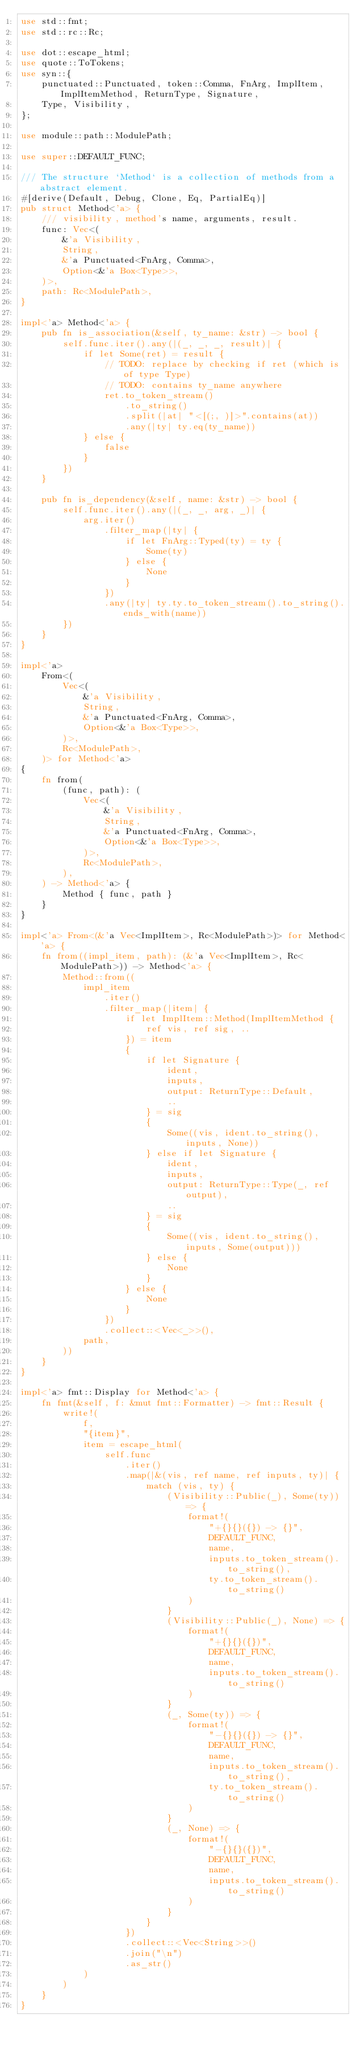<code> <loc_0><loc_0><loc_500><loc_500><_Rust_>use std::fmt;
use std::rc::Rc;

use dot::escape_html;
use quote::ToTokens;
use syn::{
    punctuated::Punctuated, token::Comma, FnArg, ImplItem, ImplItemMethod, ReturnType, Signature,
    Type, Visibility,
};

use module::path::ModulePath;

use super::DEFAULT_FUNC;

/// The structure `Method` is a collection of methods from a abstract element.
#[derive(Default, Debug, Clone, Eq, PartialEq)]
pub struct Method<'a> {
    /// visibility, method's name, arguments, result.
    func: Vec<(
        &'a Visibility,
        String,
        &'a Punctuated<FnArg, Comma>,
        Option<&'a Box<Type>>,
    )>,
    path: Rc<ModulePath>,
}

impl<'a> Method<'a> {
    pub fn is_association(&self, ty_name: &str) -> bool {
        self.func.iter().any(|(_, _, _, result)| {
            if let Some(ret) = result {
                // TODO: replace by checking if ret (which is of type Type)
                // TODO: contains ty_name anywhere
                ret.to_token_stream()
                    .to_string()
                    .split(|at| "<[(;, )]>".contains(at))
                    .any(|ty| ty.eq(ty_name))
            } else {
                false
            }
        })
    }

    pub fn is_dependency(&self, name: &str) -> bool {
        self.func.iter().any(|(_, _, arg, _)| {
            arg.iter()
                .filter_map(|ty| {
                    if let FnArg::Typed(ty) = ty {
                        Some(ty)
                    } else {
                        None
                    }
                })
                .any(|ty| ty.ty.to_token_stream().to_string().ends_with(name))
        })
    }
}

impl<'a>
    From<(
        Vec<(
            &'a Visibility,
            String,
            &'a Punctuated<FnArg, Comma>,
            Option<&'a Box<Type>>,
        )>,
        Rc<ModulePath>,
    )> for Method<'a>
{
    fn from(
        (func, path): (
            Vec<(
                &'a Visibility,
                String,
                &'a Punctuated<FnArg, Comma>,
                Option<&'a Box<Type>>,
            )>,
            Rc<ModulePath>,
        ),
    ) -> Method<'a> {
        Method { func, path }
    }
}

impl<'a> From<(&'a Vec<ImplItem>, Rc<ModulePath>)> for Method<'a> {
    fn from((impl_item, path): (&'a Vec<ImplItem>, Rc<ModulePath>)) -> Method<'a> {
        Method::from((
            impl_item
                .iter()
                .filter_map(|item| {
                    if let ImplItem::Method(ImplItemMethod {
                        ref vis, ref sig, ..
                    }) = item
                    {
                        if let Signature {
                            ident,
                            inputs,
                            output: ReturnType::Default,
                            ..
                        } = sig
                        {
                            Some((vis, ident.to_string(), inputs, None))
                        } else if let Signature {
                            ident,
                            inputs,
                            output: ReturnType::Type(_, ref output),
                            ..
                        } = sig
                        {
                            Some((vis, ident.to_string(), inputs, Some(output)))
                        } else {
                            None
                        }
                    } else {
                        None
                    }
                })
                .collect::<Vec<_>>(),
            path,
        ))
    }
}

impl<'a> fmt::Display for Method<'a> {
    fn fmt(&self, f: &mut fmt::Formatter) -> fmt::Result {
        write!(
            f,
            "{item}",
            item = escape_html(
                self.func
                    .iter()
                    .map(|&(vis, ref name, ref inputs, ty)| {
                        match (vis, ty) {
                            (Visibility::Public(_), Some(ty)) => {
                                format!(
                                    "+{}{}({}) -> {}",
                                    DEFAULT_FUNC,
                                    name,
                                    inputs.to_token_stream().to_string(),
                                    ty.to_token_stream().to_string()
                                )
                            }
                            (Visibility::Public(_), None) => {
                                format!(
                                    "+{}{}({})",
                                    DEFAULT_FUNC,
                                    name,
                                    inputs.to_token_stream().to_string()
                                )
                            }
                            (_, Some(ty)) => {
                                format!(
                                    "-{}{}({}) -> {}",
                                    DEFAULT_FUNC,
                                    name,
                                    inputs.to_token_stream().to_string(),
                                    ty.to_token_stream().to_string()
                                )
                            }
                            (_, None) => {
                                format!(
                                    "-{}{}({})",
                                    DEFAULT_FUNC,
                                    name,
                                    inputs.to_token_stream().to_string()
                                )
                            }
                        }
                    })
                    .collect::<Vec<String>>()
                    .join("\n")
                    .as_str()
            )
        )
    }
}
</code> 